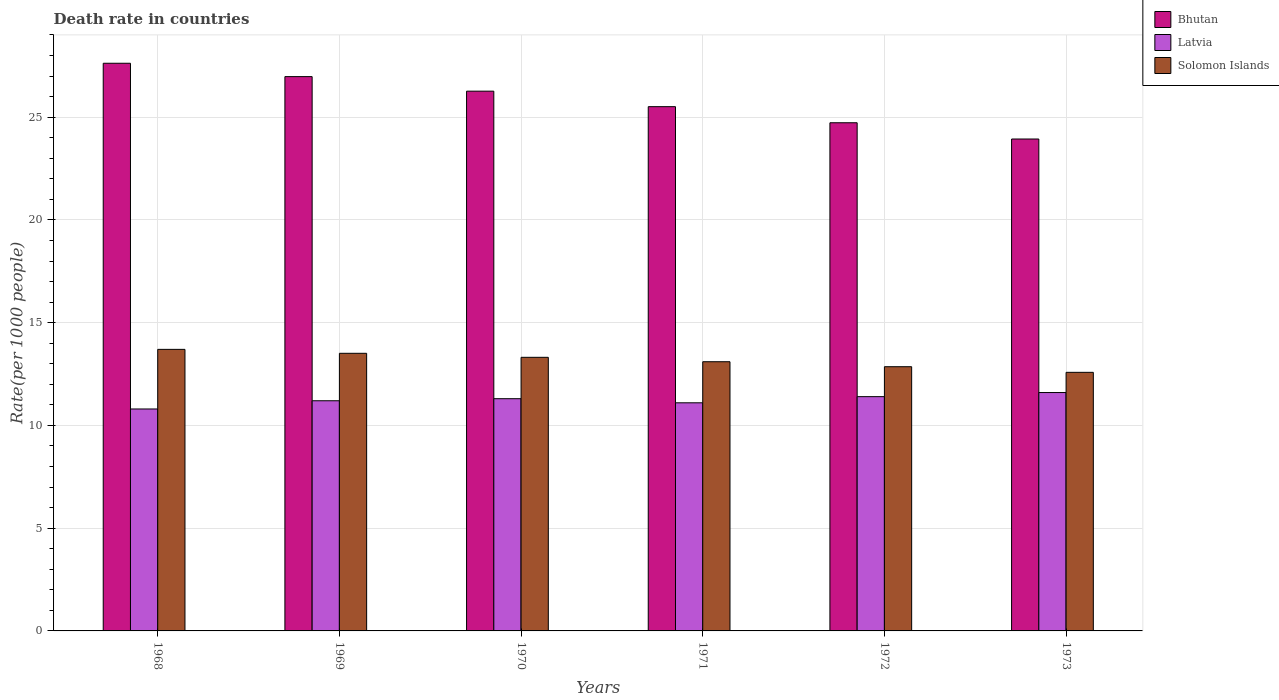How many groups of bars are there?
Keep it short and to the point. 6. How many bars are there on the 6th tick from the left?
Offer a terse response. 3. How many bars are there on the 3rd tick from the right?
Offer a very short reply. 3. What is the label of the 6th group of bars from the left?
Offer a very short reply. 1973. What is the death rate in Bhutan in 1968?
Your answer should be very brief. 27.62. Across all years, what is the maximum death rate in Bhutan?
Ensure brevity in your answer.  27.62. Across all years, what is the minimum death rate in Latvia?
Your response must be concise. 10.8. In which year was the death rate in Latvia maximum?
Make the answer very short. 1973. In which year was the death rate in Bhutan minimum?
Provide a succinct answer. 1973. What is the total death rate in Solomon Islands in the graph?
Offer a very short reply. 79.06. What is the difference between the death rate in Solomon Islands in 1970 and that in 1971?
Offer a very short reply. 0.21. What is the difference between the death rate in Solomon Islands in 1970 and the death rate in Latvia in 1971?
Provide a succinct answer. 2.21. What is the average death rate in Solomon Islands per year?
Make the answer very short. 13.18. In the year 1971, what is the difference between the death rate in Latvia and death rate in Bhutan?
Provide a succinct answer. -14.41. In how many years, is the death rate in Latvia greater than 20?
Your answer should be very brief. 0. What is the ratio of the death rate in Solomon Islands in 1969 to that in 1970?
Your answer should be compact. 1.01. What is the difference between the highest and the second highest death rate in Bhutan?
Your response must be concise. 0.65. What is the difference between the highest and the lowest death rate in Latvia?
Your response must be concise. 0.8. In how many years, is the death rate in Solomon Islands greater than the average death rate in Solomon Islands taken over all years?
Ensure brevity in your answer.  3. What does the 2nd bar from the left in 1972 represents?
Make the answer very short. Latvia. What does the 1st bar from the right in 1973 represents?
Provide a short and direct response. Solomon Islands. How many bars are there?
Your response must be concise. 18. How many years are there in the graph?
Provide a succinct answer. 6. Does the graph contain any zero values?
Provide a succinct answer. No. Does the graph contain grids?
Provide a succinct answer. Yes. Where does the legend appear in the graph?
Make the answer very short. Top right. How many legend labels are there?
Your answer should be very brief. 3. What is the title of the graph?
Provide a succinct answer. Death rate in countries. Does "Venezuela" appear as one of the legend labels in the graph?
Your answer should be compact. No. What is the label or title of the X-axis?
Provide a succinct answer. Years. What is the label or title of the Y-axis?
Offer a very short reply. Rate(per 1000 people). What is the Rate(per 1000 people) of Bhutan in 1968?
Offer a terse response. 27.62. What is the Rate(per 1000 people) of Solomon Islands in 1968?
Your answer should be compact. 13.7. What is the Rate(per 1000 people) in Bhutan in 1969?
Make the answer very short. 26.97. What is the Rate(per 1000 people) of Latvia in 1969?
Give a very brief answer. 11.2. What is the Rate(per 1000 people) of Solomon Islands in 1969?
Your answer should be very brief. 13.51. What is the Rate(per 1000 people) of Bhutan in 1970?
Ensure brevity in your answer.  26.27. What is the Rate(per 1000 people) in Solomon Islands in 1970?
Provide a short and direct response. 13.31. What is the Rate(per 1000 people) in Bhutan in 1971?
Provide a succinct answer. 25.51. What is the Rate(per 1000 people) of Solomon Islands in 1971?
Ensure brevity in your answer.  13.1. What is the Rate(per 1000 people) in Bhutan in 1972?
Provide a short and direct response. 24.73. What is the Rate(per 1000 people) of Latvia in 1972?
Your response must be concise. 11.4. What is the Rate(per 1000 people) of Solomon Islands in 1972?
Keep it short and to the point. 12.86. What is the Rate(per 1000 people) of Bhutan in 1973?
Give a very brief answer. 23.94. What is the Rate(per 1000 people) in Latvia in 1973?
Your answer should be very brief. 11.6. What is the Rate(per 1000 people) in Solomon Islands in 1973?
Make the answer very short. 12.58. Across all years, what is the maximum Rate(per 1000 people) of Bhutan?
Give a very brief answer. 27.62. Across all years, what is the maximum Rate(per 1000 people) in Solomon Islands?
Give a very brief answer. 13.7. Across all years, what is the minimum Rate(per 1000 people) of Bhutan?
Your answer should be very brief. 23.94. Across all years, what is the minimum Rate(per 1000 people) in Solomon Islands?
Your answer should be very brief. 12.58. What is the total Rate(per 1000 people) in Bhutan in the graph?
Keep it short and to the point. 155.04. What is the total Rate(per 1000 people) of Latvia in the graph?
Keep it short and to the point. 67.4. What is the total Rate(per 1000 people) of Solomon Islands in the graph?
Ensure brevity in your answer.  79.06. What is the difference between the Rate(per 1000 people) of Bhutan in 1968 and that in 1969?
Give a very brief answer. 0.65. What is the difference between the Rate(per 1000 people) of Solomon Islands in 1968 and that in 1969?
Keep it short and to the point. 0.19. What is the difference between the Rate(per 1000 people) of Bhutan in 1968 and that in 1970?
Your answer should be very brief. 1.36. What is the difference between the Rate(per 1000 people) of Solomon Islands in 1968 and that in 1970?
Your answer should be compact. 0.39. What is the difference between the Rate(per 1000 people) in Bhutan in 1968 and that in 1971?
Make the answer very short. 2.11. What is the difference between the Rate(per 1000 people) of Solomon Islands in 1968 and that in 1971?
Provide a short and direct response. 0.6. What is the difference between the Rate(per 1000 people) of Bhutan in 1968 and that in 1972?
Offer a very short reply. 2.9. What is the difference between the Rate(per 1000 people) of Latvia in 1968 and that in 1972?
Provide a short and direct response. -0.6. What is the difference between the Rate(per 1000 people) in Solomon Islands in 1968 and that in 1972?
Your answer should be very brief. 0.84. What is the difference between the Rate(per 1000 people) in Bhutan in 1968 and that in 1973?
Give a very brief answer. 3.69. What is the difference between the Rate(per 1000 people) in Solomon Islands in 1968 and that in 1973?
Ensure brevity in your answer.  1.12. What is the difference between the Rate(per 1000 people) of Bhutan in 1969 and that in 1970?
Your answer should be very brief. 0.71. What is the difference between the Rate(per 1000 people) of Solomon Islands in 1969 and that in 1970?
Ensure brevity in your answer.  0.2. What is the difference between the Rate(per 1000 people) in Bhutan in 1969 and that in 1971?
Offer a terse response. 1.46. What is the difference between the Rate(per 1000 people) in Latvia in 1969 and that in 1971?
Keep it short and to the point. 0.1. What is the difference between the Rate(per 1000 people) of Solomon Islands in 1969 and that in 1971?
Offer a terse response. 0.41. What is the difference between the Rate(per 1000 people) in Bhutan in 1969 and that in 1972?
Ensure brevity in your answer.  2.25. What is the difference between the Rate(per 1000 people) of Solomon Islands in 1969 and that in 1972?
Your response must be concise. 0.65. What is the difference between the Rate(per 1000 people) in Bhutan in 1969 and that in 1973?
Offer a very short reply. 3.04. What is the difference between the Rate(per 1000 people) in Latvia in 1969 and that in 1973?
Offer a terse response. -0.4. What is the difference between the Rate(per 1000 people) in Solomon Islands in 1969 and that in 1973?
Offer a very short reply. 0.93. What is the difference between the Rate(per 1000 people) in Bhutan in 1970 and that in 1971?
Keep it short and to the point. 0.75. What is the difference between the Rate(per 1000 people) of Latvia in 1970 and that in 1971?
Make the answer very short. 0.2. What is the difference between the Rate(per 1000 people) in Solomon Islands in 1970 and that in 1971?
Give a very brief answer. 0.21. What is the difference between the Rate(per 1000 people) in Bhutan in 1970 and that in 1972?
Keep it short and to the point. 1.54. What is the difference between the Rate(per 1000 people) in Latvia in 1970 and that in 1972?
Keep it short and to the point. -0.1. What is the difference between the Rate(per 1000 people) in Solomon Islands in 1970 and that in 1972?
Make the answer very short. 0.46. What is the difference between the Rate(per 1000 people) of Bhutan in 1970 and that in 1973?
Ensure brevity in your answer.  2.33. What is the difference between the Rate(per 1000 people) of Latvia in 1970 and that in 1973?
Your response must be concise. -0.3. What is the difference between the Rate(per 1000 people) of Solomon Islands in 1970 and that in 1973?
Keep it short and to the point. 0.73. What is the difference between the Rate(per 1000 people) of Bhutan in 1971 and that in 1972?
Ensure brevity in your answer.  0.78. What is the difference between the Rate(per 1000 people) in Solomon Islands in 1971 and that in 1972?
Your answer should be compact. 0.24. What is the difference between the Rate(per 1000 people) in Bhutan in 1971 and that in 1973?
Your answer should be very brief. 1.57. What is the difference between the Rate(per 1000 people) of Solomon Islands in 1971 and that in 1973?
Offer a very short reply. 0.52. What is the difference between the Rate(per 1000 people) of Bhutan in 1972 and that in 1973?
Your answer should be very brief. 0.79. What is the difference between the Rate(per 1000 people) of Latvia in 1972 and that in 1973?
Provide a short and direct response. -0.2. What is the difference between the Rate(per 1000 people) of Solomon Islands in 1972 and that in 1973?
Offer a very short reply. 0.27. What is the difference between the Rate(per 1000 people) of Bhutan in 1968 and the Rate(per 1000 people) of Latvia in 1969?
Make the answer very short. 16.42. What is the difference between the Rate(per 1000 people) of Bhutan in 1968 and the Rate(per 1000 people) of Solomon Islands in 1969?
Your response must be concise. 14.11. What is the difference between the Rate(per 1000 people) in Latvia in 1968 and the Rate(per 1000 people) in Solomon Islands in 1969?
Your answer should be very brief. -2.71. What is the difference between the Rate(per 1000 people) in Bhutan in 1968 and the Rate(per 1000 people) in Latvia in 1970?
Give a very brief answer. 16.32. What is the difference between the Rate(per 1000 people) in Bhutan in 1968 and the Rate(per 1000 people) in Solomon Islands in 1970?
Give a very brief answer. 14.31. What is the difference between the Rate(per 1000 people) of Latvia in 1968 and the Rate(per 1000 people) of Solomon Islands in 1970?
Your answer should be compact. -2.51. What is the difference between the Rate(per 1000 people) of Bhutan in 1968 and the Rate(per 1000 people) of Latvia in 1971?
Ensure brevity in your answer.  16.52. What is the difference between the Rate(per 1000 people) in Bhutan in 1968 and the Rate(per 1000 people) in Solomon Islands in 1971?
Give a very brief answer. 14.52. What is the difference between the Rate(per 1000 people) of Latvia in 1968 and the Rate(per 1000 people) of Solomon Islands in 1971?
Make the answer very short. -2.3. What is the difference between the Rate(per 1000 people) in Bhutan in 1968 and the Rate(per 1000 people) in Latvia in 1972?
Provide a short and direct response. 16.22. What is the difference between the Rate(per 1000 people) in Bhutan in 1968 and the Rate(per 1000 people) in Solomon Islands in 1972?
Your answer should be compact. 14.77. What is the difference between the Rate(per 1000 people) of Latvia in 1968 and the Rate(per 1000 people) of Solomon Islands in 1972?
Give a very brief answer. -2.06. What is the difference between the Rate(per 1000 people) in Bhutan in 1968 and the Rate(per 1000 people) in Latvia in 1973?
Ensure brevity in your answer.  16.02. What is the difference between the Rate(per 1000 people) in Bhutan in 1968 and the Rate(per 1000 people) in Solomon Islands in 1973?
Give a very brief answer. 15.04. What is the difference between the Rate(per 1000 people) in Latvia in 1968 and the Rate(per 1000 people) in Solomon Islands in 1973?
Your answer should be very brief. -1.78. What is the difference between the Rate(per 1000 people) of Bhutan in 1969 and the Rate(per 1000 people) of Latvia in 1970?
Your answer should be very brief. 15.67. What is the difference between the Rate(per 1000 people) in Bhutan in 1969 and the Rate(per 1000 people) in Solomon Islands in 1970?
Ensure brevity in your answer.  13.66. What is the difference between the Rate(per 1000 people) in Latvia in 1969 and the Rate(per 1000 people) in Solomon Islands in 1970?
Give a very brief answer. -2.11. What is the difference between the Rate(per 1000 people) in Bhutan in 1969 and the Rate(per 1000 people) in Latvia in 1971?
Give a very brief answer. 15.87. What is the difference between the Rate(per 1000 people) of Bhutan in 1969 and the Rate(per 1000 people) of Solomon Islands in 1971?
Make the answer very short. 13.87. What is the difference between the Rate(per 1000 people) in Latvia in 1969 and the Rate(per 1000 people) in Solomon Islands in 1971?
Offer a terse response. -1.9. What is the difference between the Rate(per 1000 people) in Bhutan in 1969 and the Rate(per 1000 people) in Latvia in 1972?
Your answer should be compact. 15.57. What is the difference between the Rate(per 1000 people) of Bhutan in 1969 and the Rate(per 1000 people) of Solomon Islands in 1972?
Provide a succinct answer. 14.12. What is the difference between the Rate(per 1000 people) of Latvia in 1969 and the Rate(per 1000 people) of Solomon Islands in 1972?
Your answer should be compact. -1.66. What is the difference between the Rate(per 1000 people) of Bhutan in 1969 and the Rate(per 1000 people) of Latvia in 1973?
Make the answer very short. 15.37. What is the difference between the Rate(per 1000 people) in Bhutan in 1969 and the Rate(per 1000 people) in Solomon Islands in 1973?
Offer a terse response. 14.39. What is the difference between the Rate(per 1000 people) in Latvia in 1969 and the Rate(per 1000 people) in Solomon Islands in 1973?
Your answer should be very brief. -1.38. What is the difference between the Rate(per 1000 people) of Bhutan in 1970 and the Rate(per 1000 people) of Latvia in 1971?
Your response must be concise. 15.16. What is the difference between the Rate(per 1000 people) of Bhutan in 1970 and the Rate(per 1000 people) of Solomon Islands in 1971?
Your answer should be very brief. 13.17. What is the difference between the Rate(per 1000 people) in Latvia in 1970 and the Rate(per 1000 people) in Solomon Islands in 1971?
Your response must be concise. -1.8. What is the difference between the Rate(per 1000 people) in Bhutan in 1970 and the Rate(per 1000 people) in Latvia in 1972?
Your response must be concise. 14.87. What is the difference between the Rate(per 1000 people) in Bhutan in 1970 and the Rate(per 1000 people) in Solomon Islands in 1972?
Offer a terse response. 13.41. What is the difference between the Rate(per 1000 people) of Latvia in 1970 and the Rate(per 1000 people) of Solomon Islands in 1972?
Make the answer very short. -1.56. What is the difference between the Rate(per 1000 people) of Bhutan in 1970 and the Rate(per 1000 people) of Latvia in 1973?
Your response must be concise. 14.66. What is the difference between the Rate(per 1000 people) in Bhutan in 1970 and the Rate(per 1000 people) in Solomon Islands in 1973?
Ensure brevity in your answer.  13.68. What is the difference between the Rate(per 1000 people) in Latvia in 1970 and the Rate(per 1000 people) in Solomon Islands in 1973?
Your answer should be very brief. -1.28. What is the difference between the Rate(per 1000 people) in Bhutan in 1971 and the Rate(per 1000 people) in Latvia in 1972?
Ensure brevity in your answer.  14.11. What is the difference between the Rate(per 1000 people) of Bhutan in 1971 and the Rate(per 1000 people) of Solomon Islands in 1972?
Your answer should be compact. 12.65. What is the difference between the Rate(per 1000 people) in Latvia in 1971 and the Rate(per 1000 people) in Solomon Islands in 1972?
Make the answer very short. -1.76. What is the difference between the Rate(per 1000 people) of Bhutan in 1971 and the Rate(per 1000 people) of Latvia in 1973?
Give a very brief answer. 13.91. What is the difference between the Rate(per 1000 people) in Bhutan in 1971 and the Rate(per 1000 people) in Solomon Islands in 1973?
Offer a terse response. 12.93. What is the difference between the Rate(per 1000 people) of Latvia in 1971 and the Rate(per 1000 people) of Solomon Islands in 1973?
Your answer should be very brief. -1.48. What is the difference between the Rate(per 1000 people) in Bhutan in 1972 and the Rate(per 1000 people) in Latvia in 1973?
Keep it short and to the point. 13.13. What is the difference between the Rate(per 1000 people) in Bhutan in 1972 and the Rate(per 1000 people) in Solomon Islands in 1973?
Your response must be concise. 12.14. What is the difference between the Rate(per 1000 people) in Latvia in 1972 and the Rate(per 1000 people) in Solomon Islands in 1973?
Offer a terse response. -1.18. What is the average Rate(per 1000 people) of Bhutan per year?
Your answer should be compact. 25.84. What is the average Rate(per 1000 people) in Latvia per year?
Make the answer very short. 11.23. What is the average Rate(per 1000 people) in Solomon Islands per year?
Offer a terse response. 13.18. In the year 1968, what is the difference between the Rate(per 1000 people) of Bhutan and Rate(per 1000 people) of Latvia?
Your answer should be compact. 16.82. In the year 1968, what is the difference between the Rate(per 1000 people) in Bhutan and Rate(per 1000 people) in Solomon Islands?
Your answer should be very brief. 13.92. In the year 1968, what is the difference between the Rate(per 1000 people) in Latvia and Rate(per 1000 people) in Solomon Islands?
Your response must be concise. -2.9. In the year 1969, what is the difference between the Rate(per 1000 people) in Bhutan and Rate(per 1000 people) in Latvia?
Provide a short and direct response. 15.77. In the year 1969, what is the difference between the Rate(per 1000 people) of Bhutan and Rate(per 1000 people) of Solomon Islands?
Offer a very short reply. 13.46. In the year 1969, what is the difference between the Rate(per 1000 people) of Latvia and Rate(per 1000 people) of Solomon Islands?
Provide a succinct answer. -2.31. In the year 1970, what is the difference between the Rate(per 1000 people) of Bhutan and Rate(per 1000 people) of Latvia?
Offer a terse response. 14.96. In the year 1970, what is the difference between the Rate(per 1000 people) in Bhutan and Rate(per 1000 people) in Solomon Islands?
Keep it short and to the point. 12.95. In the year 1970, what is the difference between the Rate(per 1000 people) of Latvia and Rate(per 1000 people) of Solomon Islands?
Your answer should be compact. -2.01. In the year 1971, what is the difference between the Rate(per 1000 people) in Bhutan and Rate(per 1000 people) in Latvia?
Offer a very short reply. 14.41. In the year 1971, what is the difference between the Rate(per 1000 people) of Bhutan and Rate(per 1000 people) of Solomon Islands?
Your answer should be compact. 12.41. In the year 1971, what is the difference between the Rate(per 1000 people) of Latvia and Rate(per 1000 people) of Solomon Islands?
Give a very brief answer. -2. In the year 1972, what is the difference between the Rate(per 1000 people) of Bhutan and Rate(per 1000 people) of Latvia?
Offer a terse response. 13.33. In the year 1972, what is the difference between the Rate(per 1000 people) in Bhutan and Rate(per 1000 people) in Solomon Islands?
Offer a terse response. 11.87. In the year 1972, what is the difference between the Rate(per 1000 people) in Latvia and Rate(per 1000 people) in Solomon Islands?
Your response must be concise. -1.46. In the year 1973, what is the difference between the Rate(per 1000 people) in Bhutan and Rate(per 1000 people) in Latvia?
Make the answer very short. 12.34. In the year 1973, what is the difference between the Rate(per 1000 people) of Bhutan and Rate(per 1000 people) of Solomon Islands?
Give a very brief answer. 11.35. In the year 1973, what is the difference between the Rate(per 1000 people) in Latvia and Rate(per 1000 people) in Solomon Islands?
Provide a succinct answer. -0.98. What is the ratio of the Rate(per 1000 people) in Bhutan in 1968 to that in 1969?
Provide a succinct answer. 1.02. What is the ratio of the Rate(per 1000 people) in Latvia in 1968 to that in 1969?
Provide a succinct answer. 0.96. What is the ratio of the Rate(per 1000 people) of Solomon Islands in 1968 to that in 1969?
Provide a short and direct response. 1.01. What is the ratio of the Rate(per 1000 people) of Bhutan in 1968 to that in 1970?
Provide a succinct answer. 1.05. What is the ratio of the Rate(per 1000 people) of Latvia in 1968 to that in 1970?
Your response must be concise. 0.96. What is the ratio of the Rate(per 1000 people) in Solomon Islands in 1968 to that in 1970?
Give a very brief answer. 1.03. What is the ratio of the Rate(per 1000 people) in Bhutan in 1968 to that in 1971?
Offer a very short reply. 1.08. What is the ratio of the Rate(per 1000 people) of Solomon Islands in 1968 to that in 1971?
Your response must be concise. 1.05. What is the ratio of the Rate(per 1000 people) of Bhutan in 1968 to that in 1972?
Offer a very short reply. 1.12. What is the ratio of the Rate(per 1000 people) of Solomon Islands in 1968 to that in 1972?
Give a very brief answer. 1.07. What is the ratio of the Rate(per 1000 people) in Bhutan in 1968 to that in 1973?
Give a very brief answer. 1.15. What is the ratio of the Rate(per 1000 people) in Latvia in 1968 to that in 1973?
Give a very brief answer. 0.93. What is the ratio of the Rate(per 1000 people) of Solomon Islands in 1968 to that in 1973?
Give a very brief answer. 1.09. What is the ratio of the Rate(per 1000 people) of Latvia in 1969 to that in 1970?
Provide a short and direct response. 0.99. What is the ratio of the Rate(per 1000 people) of Solomon Islands in 1969 to that in 1970?
Your answer should be very brief. 1.01. What is the ratio of the Rate(per 1000 people) in Bhutan in 1969 to that in 1971?
Provide a short and direct response. 1.06. What is the ratio of the Rate(per 1000 people) of Solomon Islands in 1969 to that in 1971?
Your answer should be very brief. 1.03. What is the ratio of the Rate(per 1000 people) in Bhutan in 1969 to that in 1972?
Offer a terse response. 1.09. What is the ratio of the Rate(per 1000 people) in Latvia in 1969 to that in 1972?
Your answer should be compact. 0.98. What is the ratio of the Rate(per 1000 people) in Solomon Islands in 1969 to that in 1972?
Provide a succinct answer. 1.05. What is the ratio of the Rate(per 1000 people) of Bhutan in 1969 to that in 1973?
Make the answer very short. 1.13. What is the ratio of the Rate(per 1000 people) of Latvia in 1969 to that in 1973?
Your response must be concise. 0.97. What is the ratio of the Rate(per 1000 people) in Solomon Islands in 1969 to that in 1973?
Your response must be concise. 1.07. What is the ratio of the Rate(per 1000 people) of Bhutan in 1970 to that in 1971?
Your answer should be very brief. 1.03. What is the ratio of the Rate(per 1000 people) in Solomon Islands in 1970 to that in 1971?
Provide a succinct answer. 1.02. What is the ratio of the Rate(per 1000 people) in Bhutan in 1970 to that in 1972?
Make the answer very short. 1.06. What is the ratio of the Rate(per 1000 people) in Latvia in 1970 to that in 1972?
Provide a succinct answer. 0.99. What is the ratio of the Rate(per 1000 people) in Solomon Islands in 1970 to that in 1972?
Provide a succinct answer. 1.04. What is the ratio of the Rate(per 1000 people) of Bhutan in 1970 to that in 1973?
Give a very brief answer. 1.1. What is the ratio of the Rate(per 1000 people) in Latvia in 1970 to that in 1973?
Your answer should be compact. 0.97. What is the ratio of the Rate(per 1000 people) of Solomon Islands in 1970 to that in 1973?
Give a very brief answer. 1.06. What is the ratio of the Rate(per 1000 people) of Bhutan in 1971 to that in 1972?
Provide a short and direct response. 1.03. What is the ratio of the Rate(per 1000 people) in Latvia in 1971 to that in 1972?
Your answer should be compact. 0.97. What is the ratio of the Rate(per 1000 people) of Solomon Islands in 1971 to that in 1972?
Offer a terse response. 1.02. What is the ratio of the Rate(per 1000 people) in Bhutan in 1971 to that in 1973?
Your answer should be very brief. 1.07. What is the ratio of the Rate(per 1000 people) in Latvia in 1971 to that in 1973?
Your answer should be compact. 0.96. What is the ratio of the Rate(per 1000 people) of Solomon Islands in 1971 to that in 1973?
Your response must be concise. 1.04. What is the ratio of the Rate(per 1000 people) in Bhutan in 1972 to that in 1973?
Keep it short and to the point. 1.03. What is the ratio of the Rate(per 1000 people) in Latvia in 1972 to that in 1973?
Keep it short and to the point. 0.98. What is the ratio of the Rate(per 1000 people) of Solomon Islands in 1972 to that in 1973?
Offer a very short reply. 1.02. What is the difference between the highest and the second highest Rate(per 1000 people) in Bhutan?
Your answer should be compact. 0.65. What is the difference between the highest and the second highest Rate(per 1000 people) of Latvia?
Your answer should be very brief. 0.2. What is the difference between the highest and the second highest Rate(per 1000 people) in Solomon Islands?
Provide a short and direct response. 0.19. What is the difference between the highest and the lowest Rate(per 1000 people) in Bhutan?
Offer a terse response. 3.69. What is the difference between the highest and the lowest Rate(per 1000 people) in Solomon Islands?
Your answer should be very brief. 1.12. 